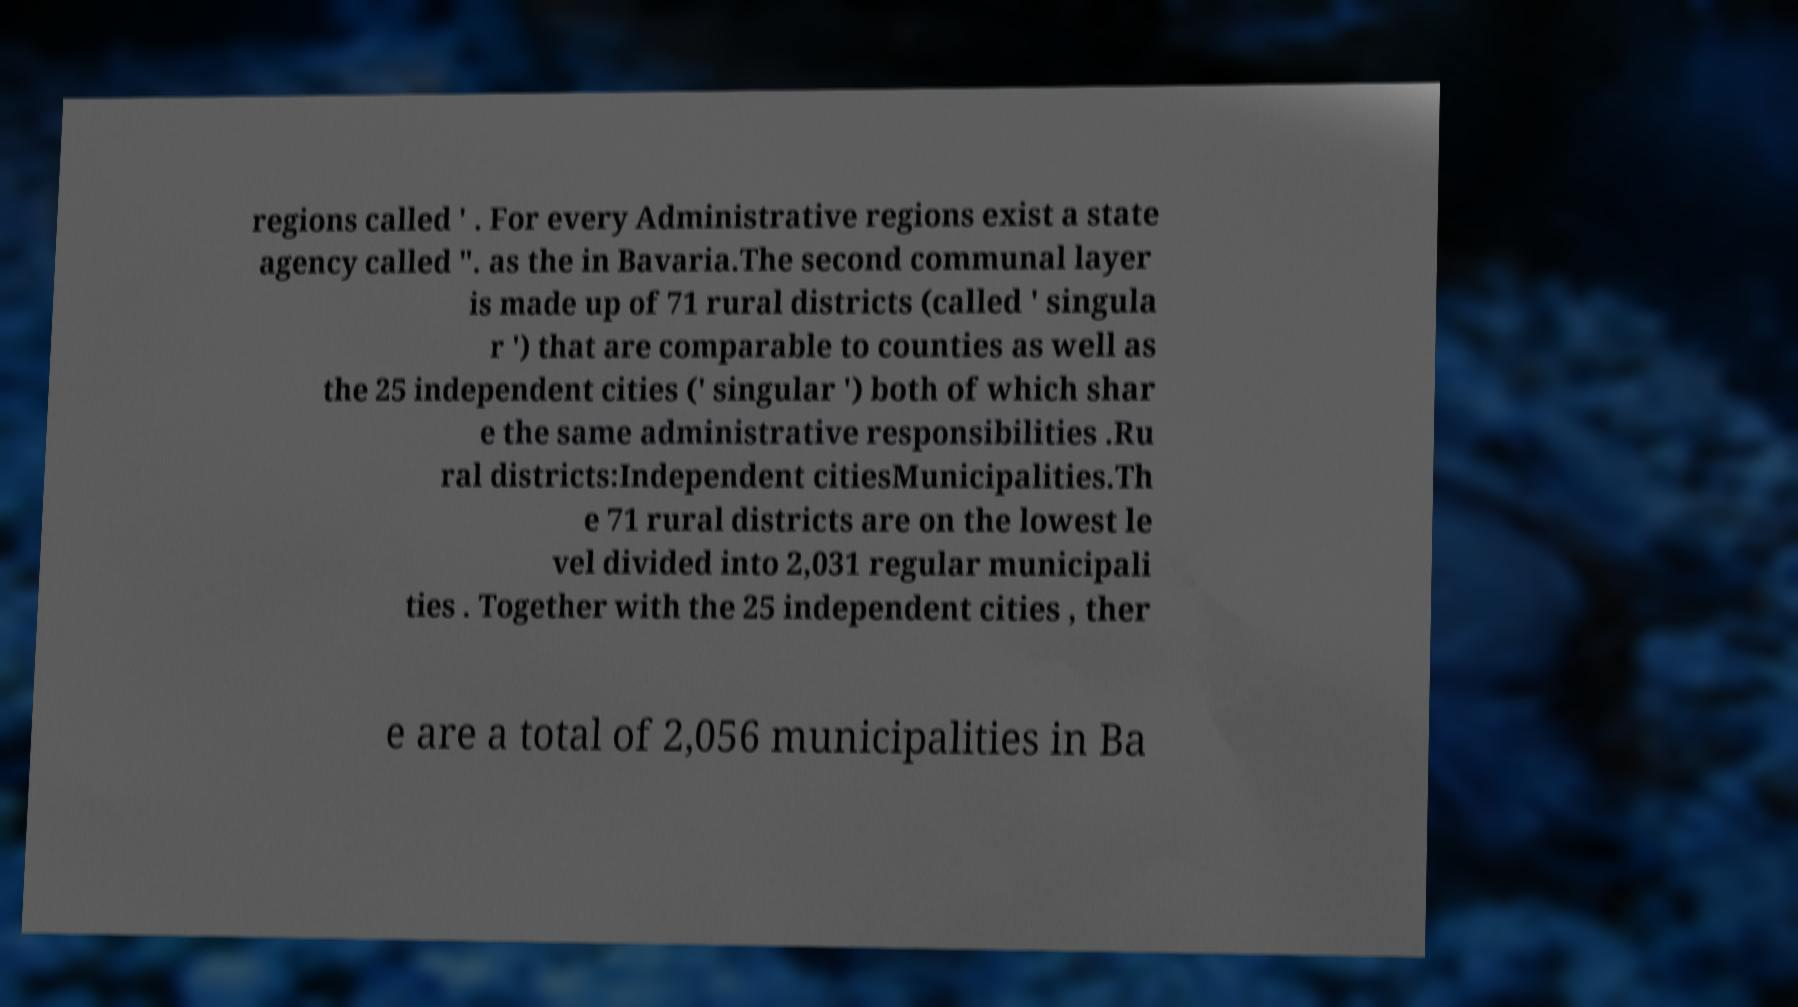Can you accurately transcribe the text from the provided image for me? regions called ' . For every Administrative regions exist a state agency called ". as the in Bavaria.The second communal layer is made up of 71 rural districts (called ' singula r ') that are comparable to counties as well as the 25 independent cities (' singular ') both of which shar e the same administrative responsibilities .Ru ral districts:Independent citiesMunicipalities.Th e 71 rural districts are on the lowest le vel divided into 2,031 regular municipali ties . Together with the 25 independent cities , ther e are a total of 2,056 municipalities in Ba 